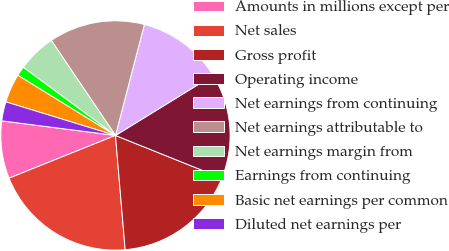Convert chart. <chart><loc_0><loc_0><loc_500><loc_500><pie_chart><fcel>Amounts in millions except per<fcel>Net sales<fcel>Gross profit<fcel>Operating income<fcel>Net earnings from continuing<fcel>Net earnings attributable to<fcel>Net earnings margin from<fcel>Earnings from continuing<fcel>Basic net earnings per common<fcel>Diluted net earnings per<nl><fcel>8.11%<fcel>20.27%<fcel>17.57%<fcel>14.86%<fcel>12.16%<fcel>13.51%<fcel>5.41%<fcel>1.35%<fcel>4.05%<fcel>2.7%<nl></chart> 